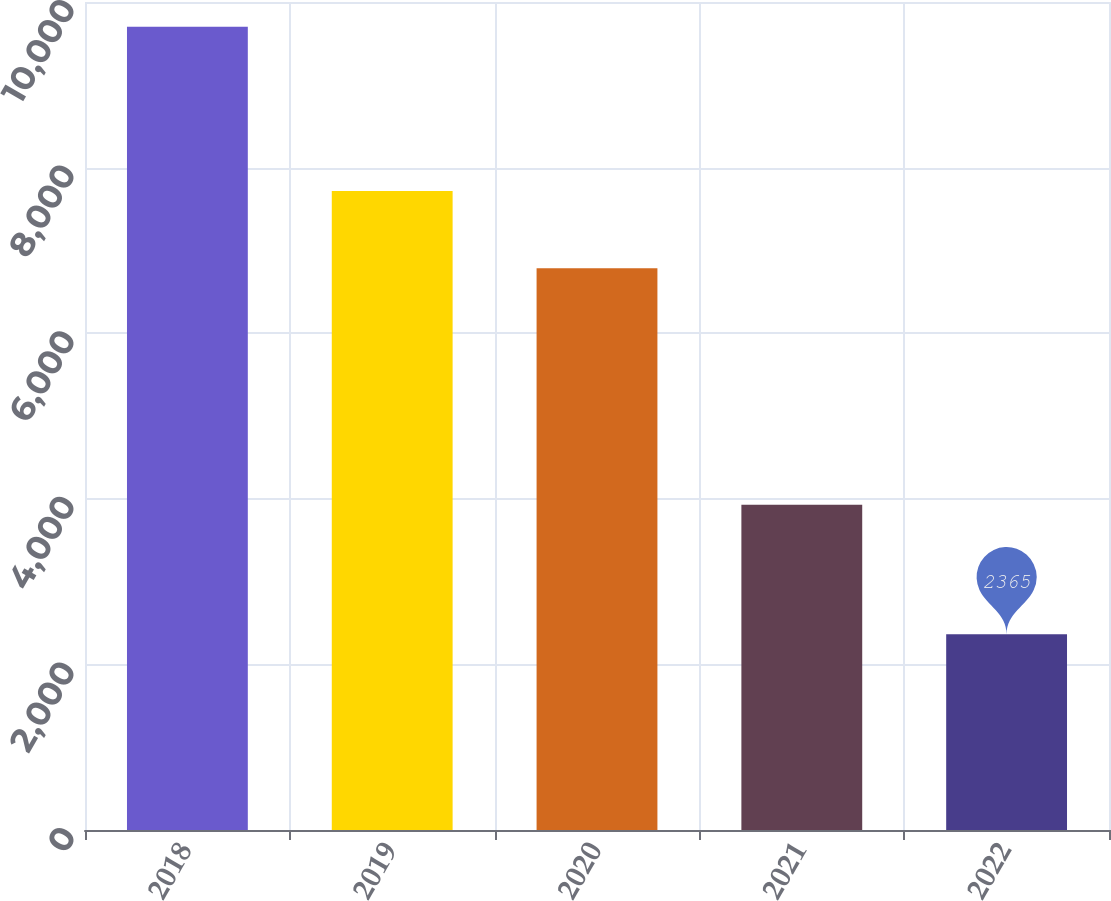<chart> <loc_0><loc_0><loc_500><loc_500><bar_chart><fcel>2018<fcel>2019<fcel>2020<fcel>2021<fcel>2022<nl><fcel>9700<fcel>7716<fcel>6783<fcel>3927<fcel>2365<nl></chart> 